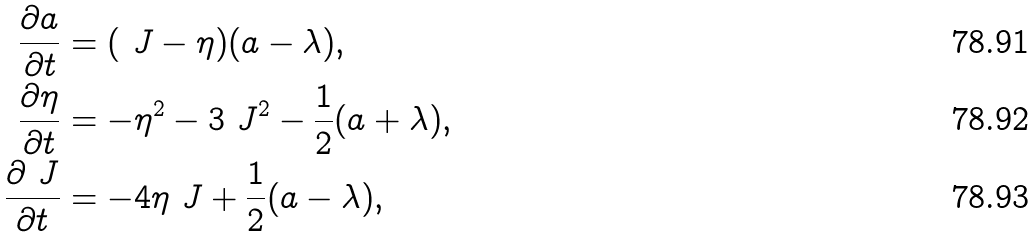<formula> <loc_0><loc_0><loc_500><loc_500>\frac { \partial a } { \partial t } & = ( \ J - \eta ) ( a - \lambda ) , \\ \frac { \partial \eta } { \partial t } & = - \eta ^ { 2 } - 3 \ J ^ { 2 } - \frac { 1 } { 2 } ( a + \lambda ) , \\ \frac { \partial \ J } { \partial t } & = - 4 \eta \ J + \frac { 1 } { 2 } ( a - \lambda ) ,</formula> 